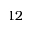<formula> <loc_0><loc_0><loc_500><loc_500>1 2</formula> 